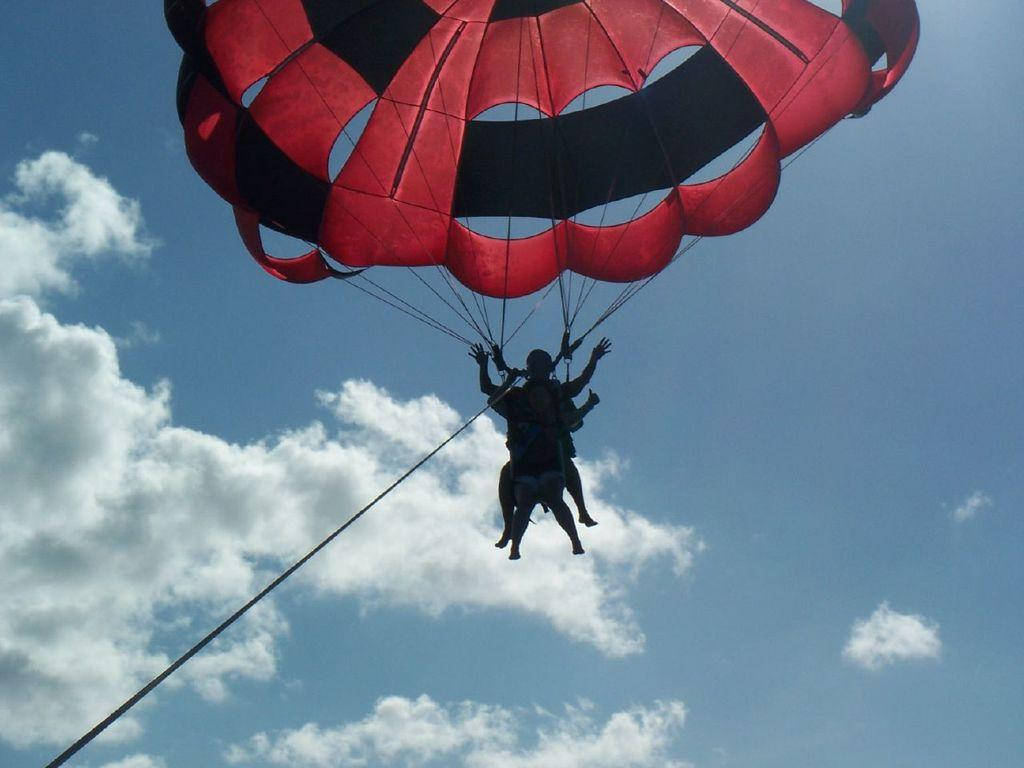What activity are the two people in the image engaged in? The two people in the image are paragliding. What is used to control the paragliders in the image? There are ropes associated with the paragliding. What can be seen in the background of the image? The sky is visible in the image. What is the weather like in the image? The sky appears to be cloudy in the image. What type of collar can be seen on the paraglider in the image? There is no collar present on the paragliders in the image, as they are not wearing clothing with collars. How many clocks are visible in the image? There are no clocks visible in the image. 